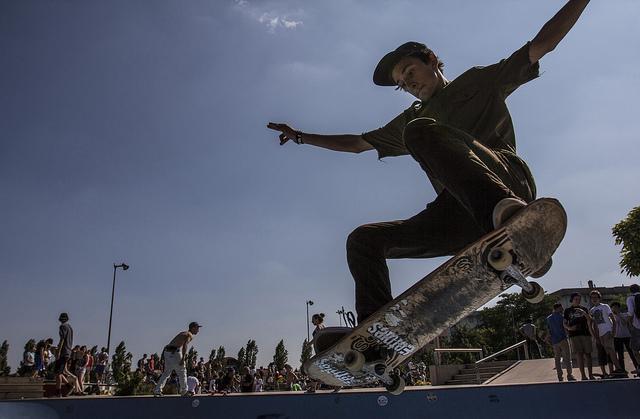How many people can you see?
Give a very brief answer. 2. How many sandwiches with orange paste are in the picture?
Give a very brief answer. 0. 